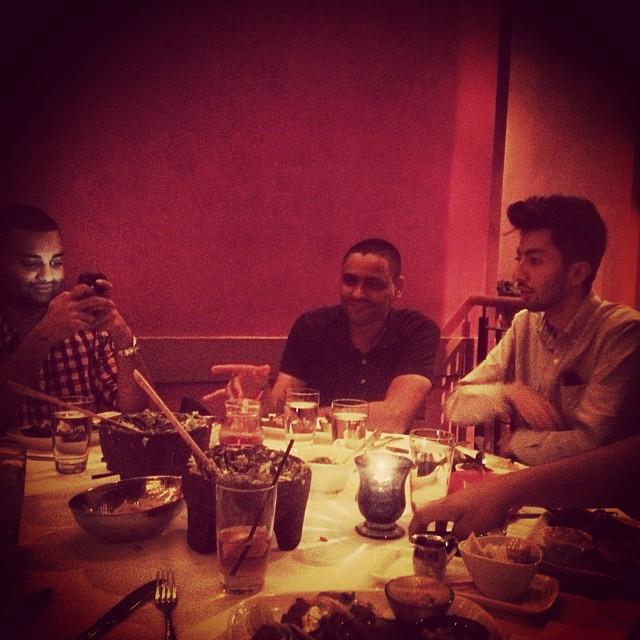What are the men doing?
Quick response, please. Eating. How many lit candles on the table?
Be succinct. 1. What color is the wall?
Quick response, please. Red. 